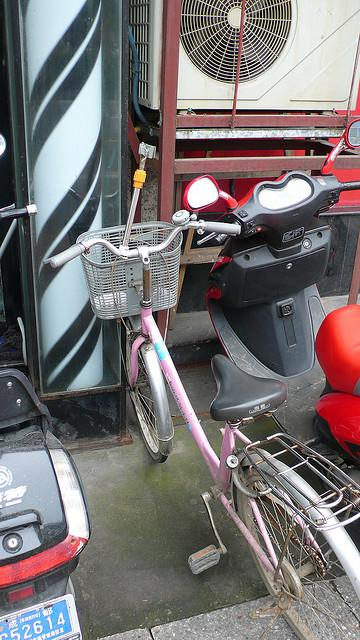What color is the frame of the girl's bike painted out to be? Please explain your reasoning. pink. Although the wheel covers are silver, the rest of this bicycle is painted pink. 